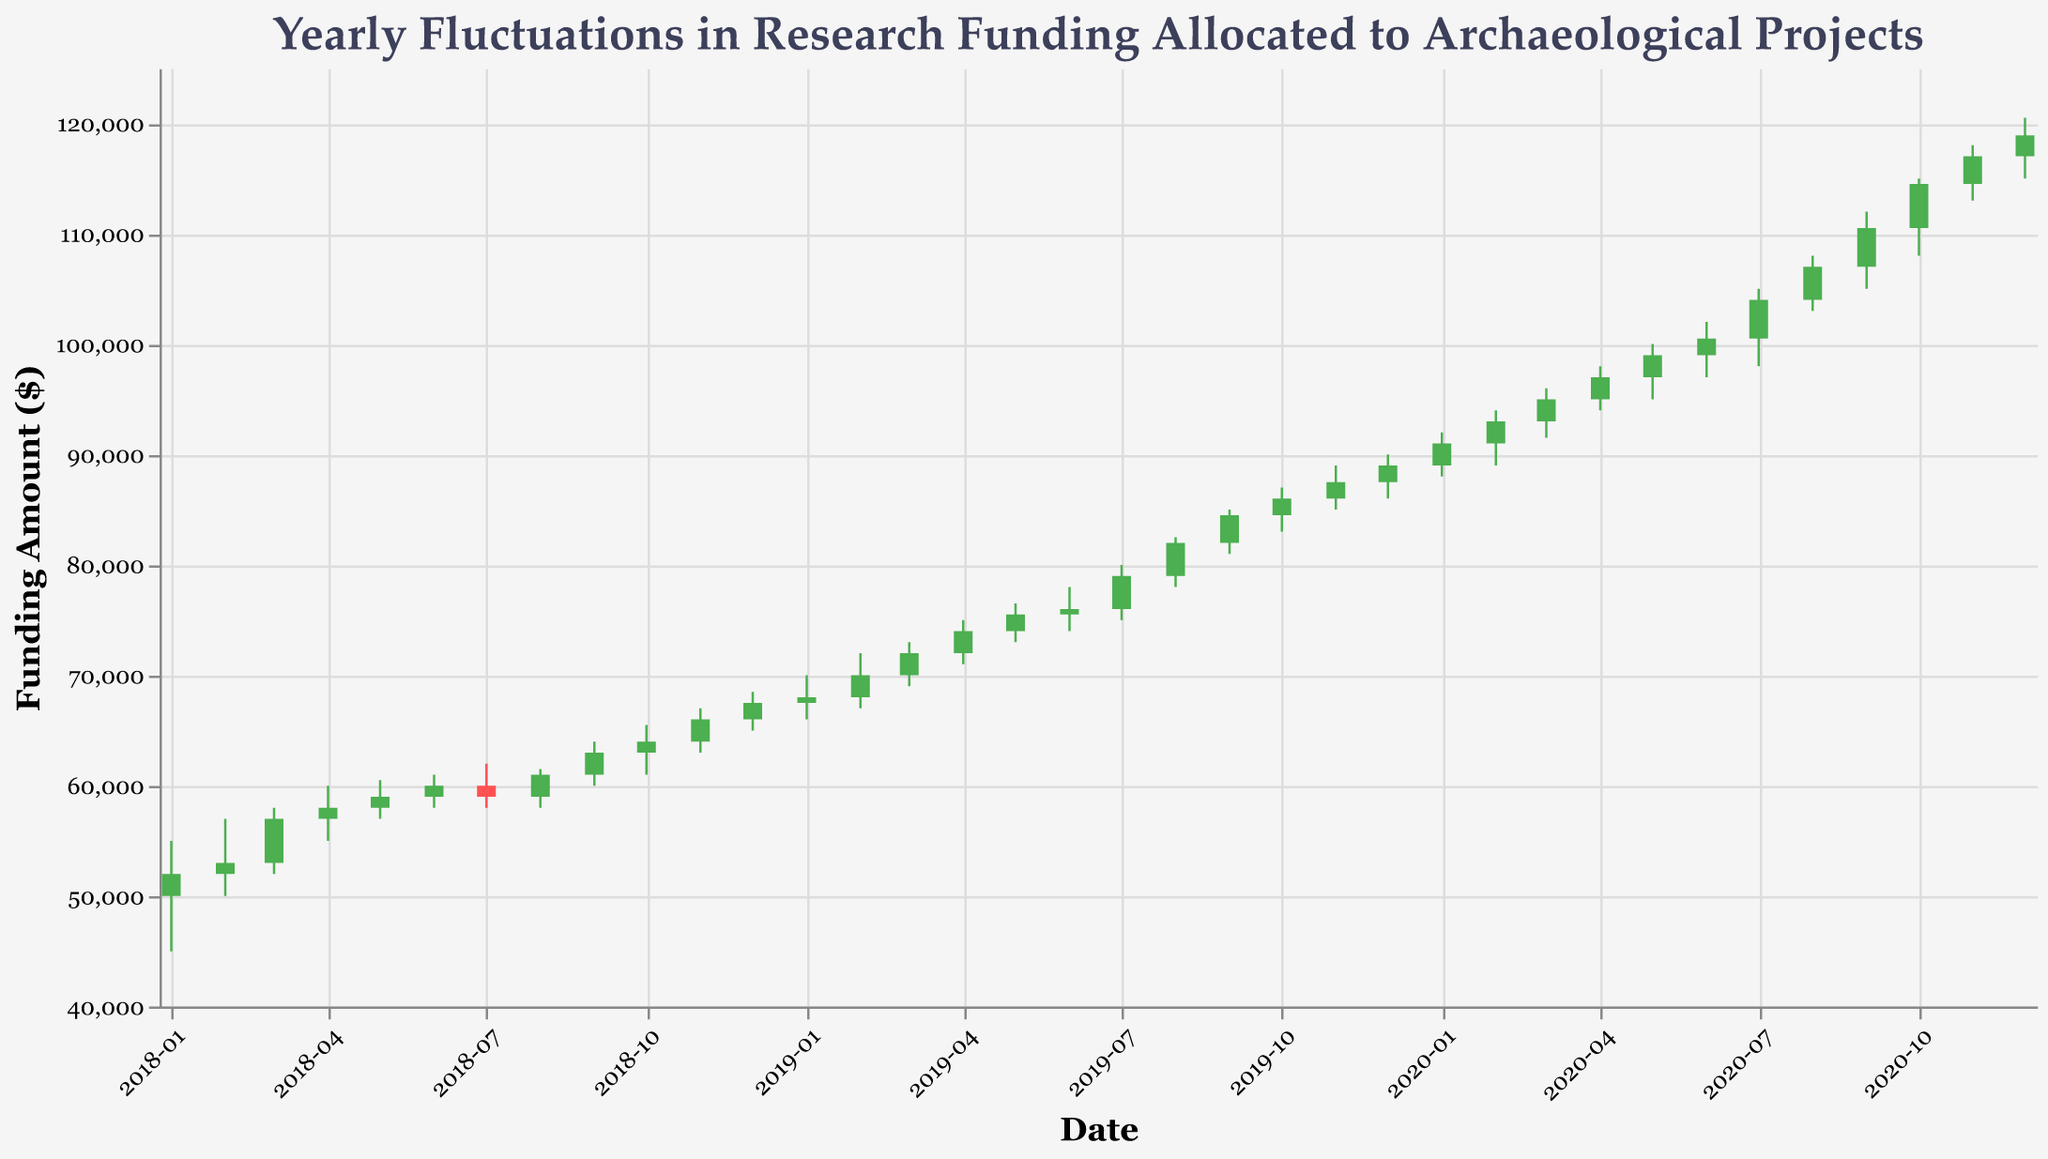What is the title of the figure? The title of the figure is displayed at the top and is generally the largest text.
Answer: Yearly Fluctuations in Research Funding Allocated to Archaeological Projects What is the highest funding amount reached in August 2019? The highest funding amount is indicated by the top end of the vertical line in the candlestick for August 2019.
Answer: 82500 What months in 2020 saw a decrease in the funding amount compared to the month before? To determine this, you must compare the closing value of each month with the closing value of the previous month. If the closing value is lower, it indicates a decrease. The months that saw a decrease are January, July, October, and December.
Answer: January, July, October, December When was the funding amount lowest in 2018, and what was this value? The lowest funding amount for the year is indicated by the bottom end of the vertical lines in 2018. The lowest value appears in January 2018.
Answer: January 2018, 45000 How many months show an increase in funding compared to the previous month? An increase is indicated by the green color of the candlestick. Counting these candlesticks, there are 26 such months.
Answer: 26 What was the average closing amount in 2019? Sum the closing amounts for each month in 2019 and divide by 12. The closing amounts are: 68000, 70000, 72000, 74000, 75500, 76000, 79000, 82000, 84500, 86000, 87500, 89000. Sum: 989000. Dividing by 12 gives: 82416.67.
Answer: 82416.67 Which month in 2018 had the smallest range (difference between the high and low values) in funding? The range is found by subtracting the low value from the high value for each month. The smallest range in 2018 is April, where the high is 60000 and the low is 55000, giving a range of 5000.
Answer: April Compare the highest funding amounts in June 2018 and June 2019. Which month had a higher funding amount and by how much? The highest funding amounts are 61000 for June 2018 and 78000 for June 2019. Subtracting 61000 from 78000 gives the difference.
Answer: June 2019 by 17000 What is the overall trend of the funding amount from January 2018 to December 2020? The trend can be observed by noting the general movement of the close prices from the start to the end of the timeline. The funding shows an overall increasing trend from 52000 in January 2018 to 118900 in December 2020.
Answer: Increasing 